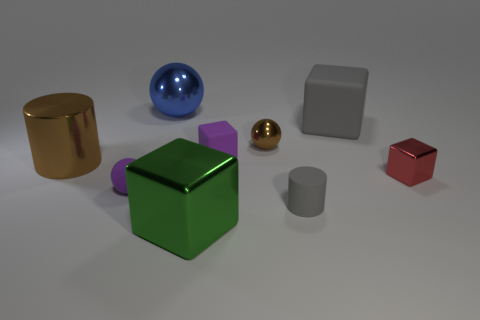Subtract 1 cubes. How many cubes are left? 3 Subtract all balls. How many objects are left? 6 Subtract all tiny brown objects. Subtract all small purple balls. How many objects are left? 7 Add 6 large blue metal things. How many large blue metal things are left? 7 Add 7 brown balls. How many brown balls exist? 8 Subtract 1 gray cylinders. How many objects are left? 8 